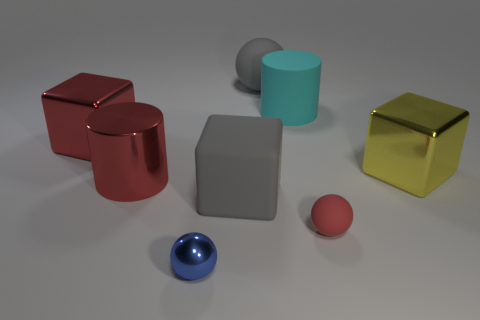How does the size of the blue sphere compare to the other objects? The blue sphere is smaller than the red metallic cylinder and the cubes, but it is larger than the small red rubber sphere. 